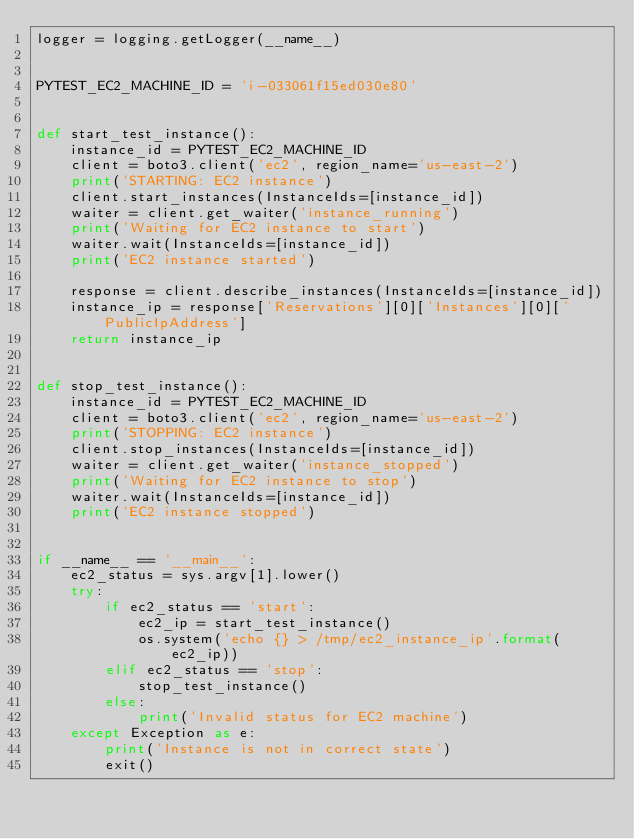Convert code to text. <code><loc_0><loc_0><loc_500><loc_500><_Python_>logger = logging.getLogger(__name__)


PYTEST_EC2_MACHINE_ID = 'i-033061f15ed030e80'


def start_test_instance():
    instance_id = PYTEST_EC2_MACHINE_ID
    client = boto3.client('ec2', region_name='us-east-2')
    print('STARTING: EC2 instance')
    client.start_instances(InstanceIds=[instance_id])
    waiter = client.get_waiter('instance_running')
    print('Waiting for EC2 instance to start')
    waiter.wait(InstanceIds=[instance_id])
    print('EC2 instance started')

    response = client.describe_instances(InstanceIds=[instance_id])
    instance_ip = response['Reservations'][0]['Instances'][0]['PublicIpAddress']
    return instance_ip


def stop_test_instance():
    instance_id = PYTEST_EC2_MACHINE_ID
    client = boto3.client('ec2', region_name='us-east-2')
    print('STOPPING: EC2 instance')
    client.stop_instances(InstanceIds=[instance_id])
    waiter = client.get_waiter('instance_stopped')
    print('Waiting for EC2 instance to stop')
    waiter.wait(InstanceIds=[instance_id])
    print('EC2 instance stopped')


if __name__ == '__main__':
    ec2_status = sys.argv[1].lower()
    try:
        if ec2_status == 'start':
            ec2_ip = start_test_instance()
            os.system('echo {} > /tmp/ec2_instance_ip'.format(ec2_ip))
        elif ec2_status == 'stop':
            stop_test_instance()
        else:
            print('Invalid status for EC2 machine')
    except Exception as e:
        print('Instance is not in correct state')
        exit()
</code> 